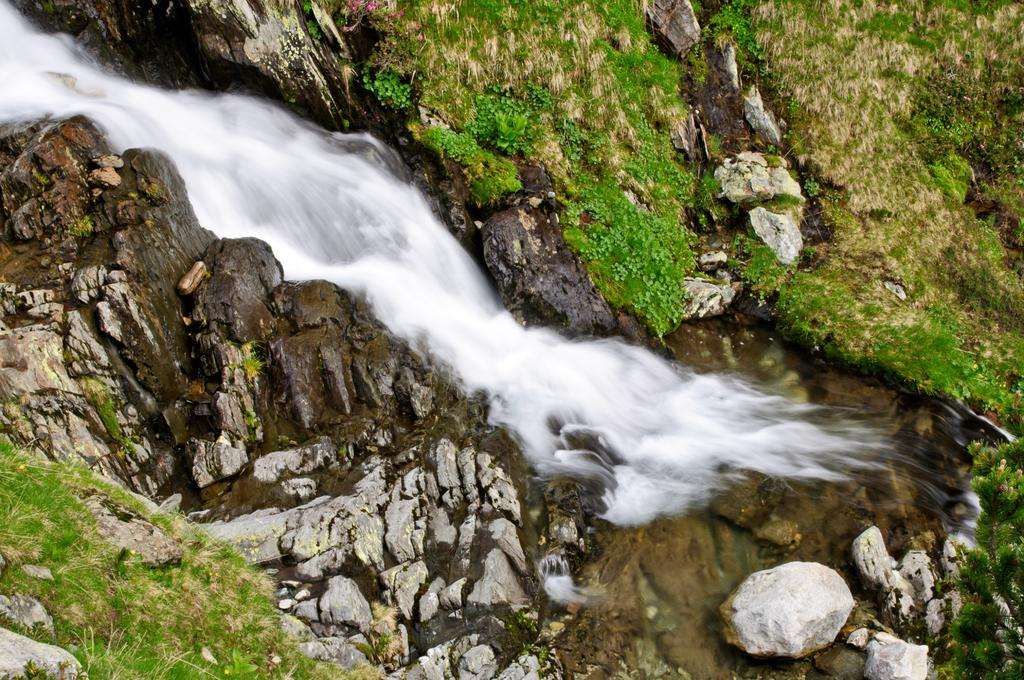What is the main feature in the center of the image? There is water in the center of the image. What can be seen on both sides of the water? There are stones on both sides of the water. What type of vegetation is present on both sides of the water? Grass is present on both sides of the water. What type of tank is visible on the grassy area in the image? There is no tank present in the image; it features water, stones, and grass. How many pages of information are provided about the image? The image itself does not contain any pages or written information, so this question cannot be answered. 